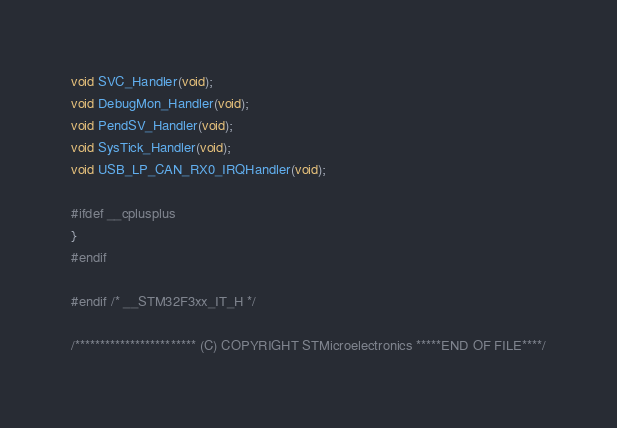Convert code to text. <code><loc_0><loc_0><loc_500><loc_500><_C_>void SVC_Handler(void);
void DebugMon_Handler(void);
void PendSV_Handler(void);
void SysTick_Handler(void);
void USB_LP_CAN_RX0_IRQHandler(void);

#ifdef __cplusplus
}
#endif

#endif /* __STM32F3xx_IT_H */

/************************ (C) COPYRIGHT STMicroelectronics *****END OF FILE****/
</code> 